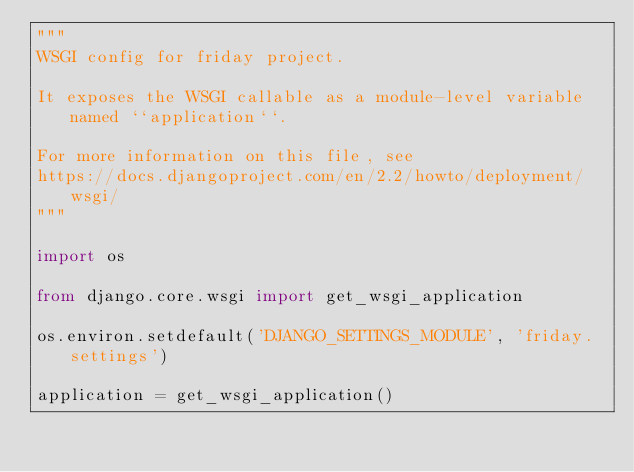<code> <loc_0><loc_0><loc_500><loc_500><_Python_>"""
WSGI config for friday project.

It exposes the WSGI callable as a module-level variable named ``application``.

For more information on this file, see
https://docs.djangoproject.com/en/2.2/howto/deployment/wsgi/
"""

import os

from django.core.wsgi import get_wsgi_application

os.environ.setdefault('DJANGO_SETTINGS_MODULE', 'friday.settings')

application = get_wsgi_application()
</code> 